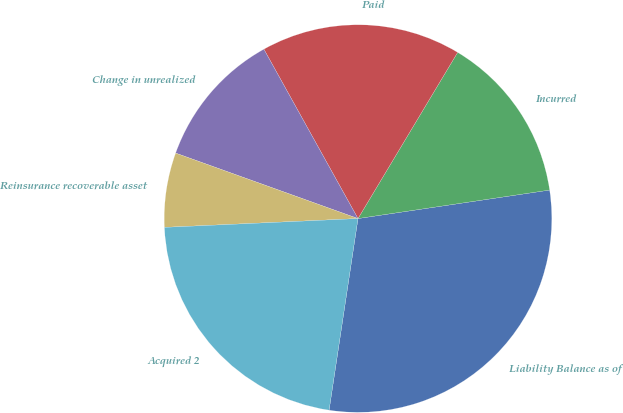<chart> <loc_0><loc_0><loc_500><loc_500><pie_chart><fcel>Liability Balance as of<fcel>Incurred<fcel>Paid<fcel>Change in unrealized<fcel>Reinsurance recoverable asset<fcel>Acquired 2<nl><fcel>29.73%<fcel>14.05%<fcel>16.67%<fcel>11.44%<fcel>6.21%<fcel>21.89%<nl></chart> 